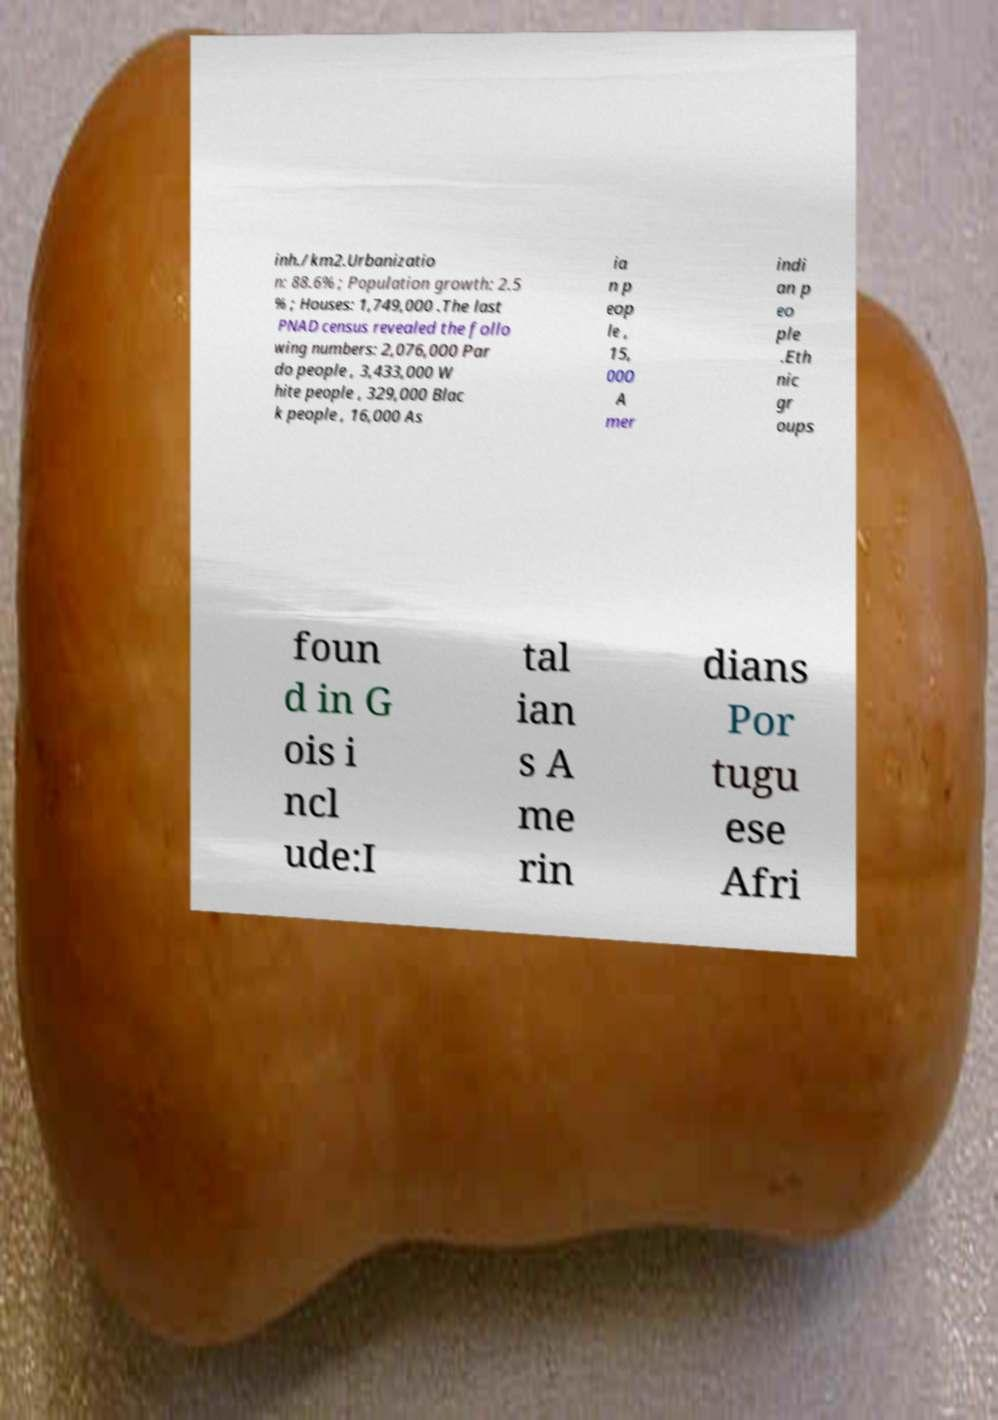Could you assist in decoding the text presented in this image and type it out clearly? inh./km2.Urbanizatio n: 88.6% ; Population growth: 2.5 % ; Houses: 1,749,000 .The last PNAD census revealed the follo wing numbers: 2,076,000 Par do people , 3,433,000 W hite people , 329,000 Blac k people , 16,000 As ia n p eop le , 15, 000 A mer indi an p eo ple .Eth nic gr oups foun d in G ois i ncl ude:I tal ian s A me rin dians Por tugu ese Afri 